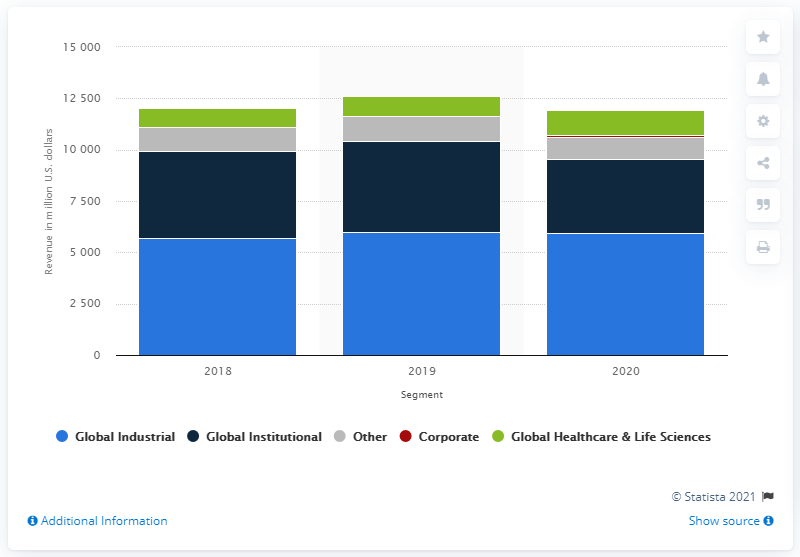Give some essential details in this illustration. In 2020, the Global Industrial segment of Ecolab generated a revenue of $59,599.9. 